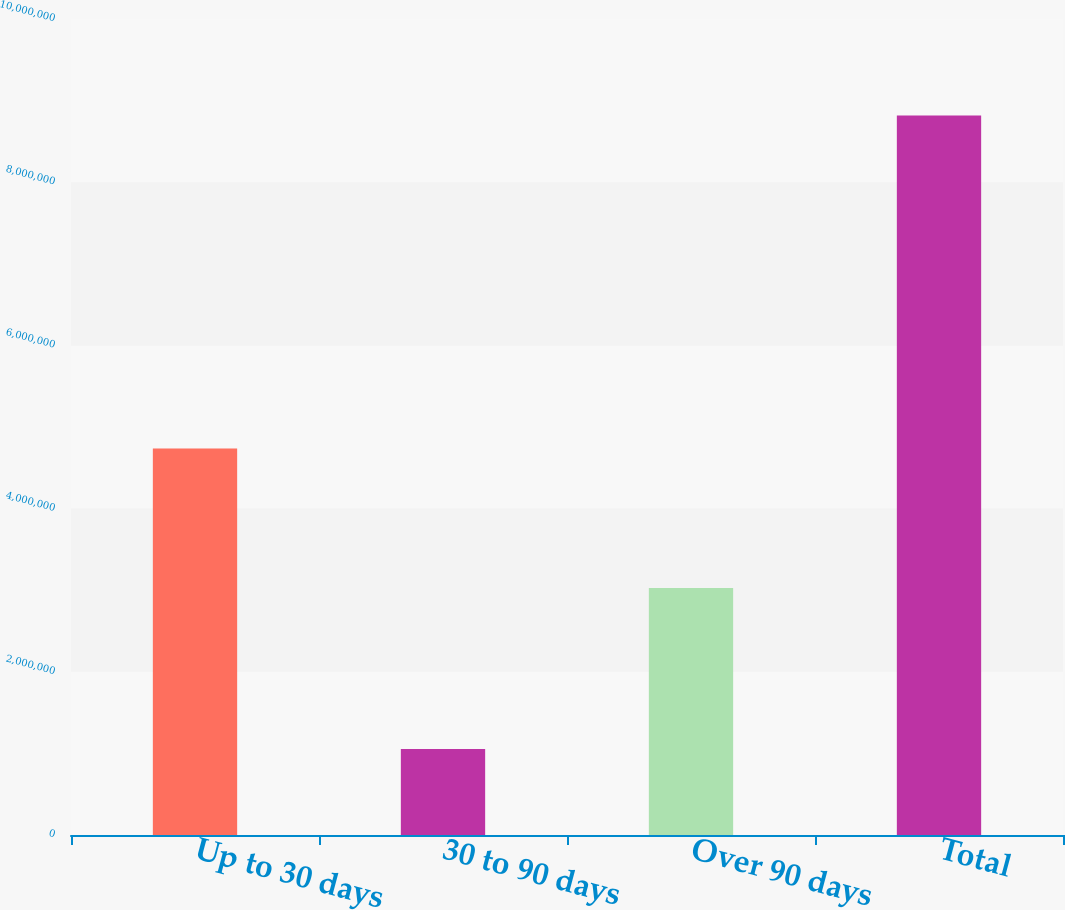<chart> <loc_0><loc_0><loc_500><loc_500><bar_chart><fcel>Up to 30 days<fcel>30 to 90 days<fcel>Over 90 days<fcel>Total<nl><fcel>4.7376e+06<fcel>1.05278e+06<fcel>3.02674e+06<fcel>8.81712e+06<nl></chart> 